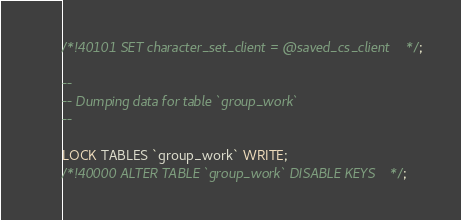Convert code to text. <code><loc_0><loc_0><loc_500><loc_500><_SQL_>/*!40101 SET character_set_client = @saved_cs_client */;

--
-- Dumping data for table `group_work`
--

LOCK TABLES `group_work` WRITE;
/*!40000 ALTER TABLE `group_work` DISABLE KEYS */;</code> 